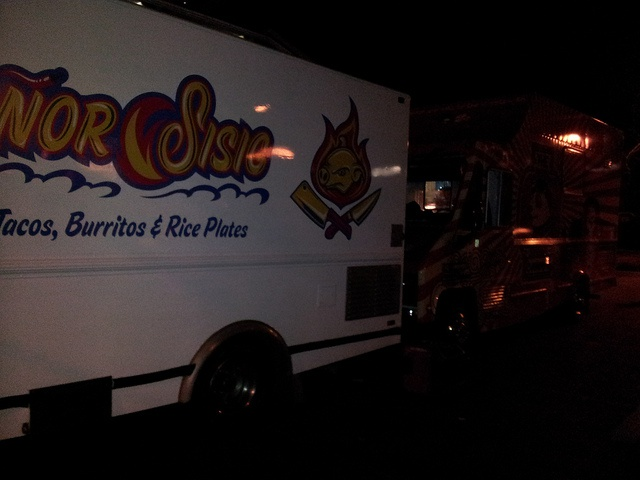Describe the objects in this image and their specific colors. I can see truck in black and gray tones, truck in black, maroon, and brown tones, knife in black tones, and knife in black tones in this image. 